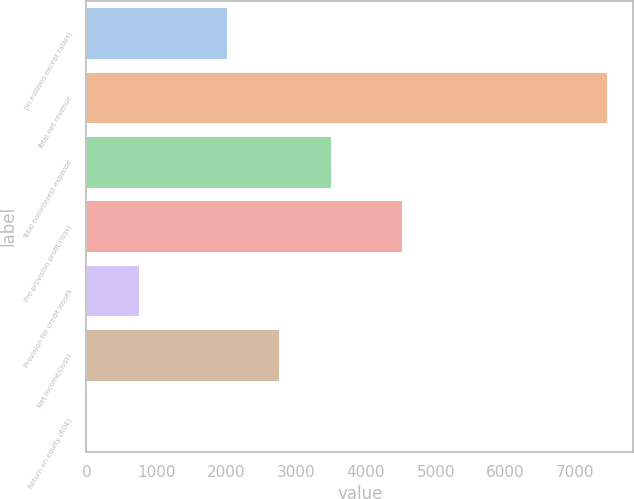Convert chart. <chart><loc_0><loc_0><loc_500><loc_500><bar_chart><fcel>(in millions except ratios)<fcel>Total net revenue<fcel>Total noninterest expense<fcel>Pre-provision profit/(loss)<fcel>Provision for credit losses<fcel>Net income/(loss)<fcel>Return on equity (ROE)<nl><fcel>2016<fcel>7453<fcel>3503.4<fcel>4519<fcel>759.7<fcel>2759.7<fcel>16<nl></chart> 